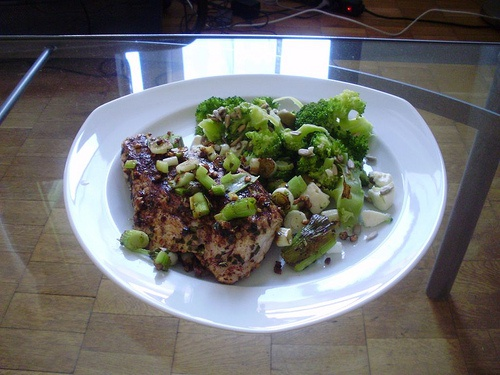Describe the objects in this image and their specific colors. I can see dining table in gray, black, white, and darkgray tones, broccoli in black, darkgreen, and olive tones, broccoli in black, darkgreen, gray, and olive tones, broccoli in black, darkgreen, and olive tones, and broccoli in black, darkgreen, darkgray, and gray tones in this image. 